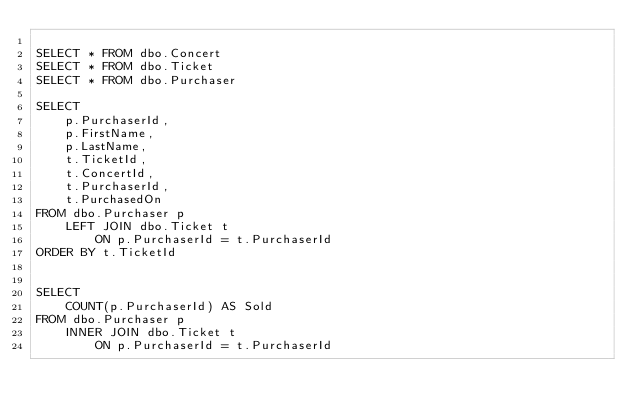<code> <loc_0><loc_0><loc_500><loc_500><_SQL_>
SELECT * FROM dbo.Concert
SELECT * FROM dbo.Ticket
SELECT * FROM dbo.Purchaser

SELECT
	p.PurchaserId,
    p.FirstName,
    p.LastName,
    t.TicketId,
    t.ConcertId,
    t.PurchaserId,
    t.PurchasedOn
FROM dbo.Purchaser p
	LEFT JOIN dbo.Ticket t
		ON p.PurchaserId = t.PurchaserId
ORDER BY t.TicketId


SELECT
	COUNT(p.PurchaserId) AS Sold
FROM dbo.Purchaser p
	INNER JOIN dbo.Ticket t
		ON p.PurchaserId = t.PurchaserId

</code> 